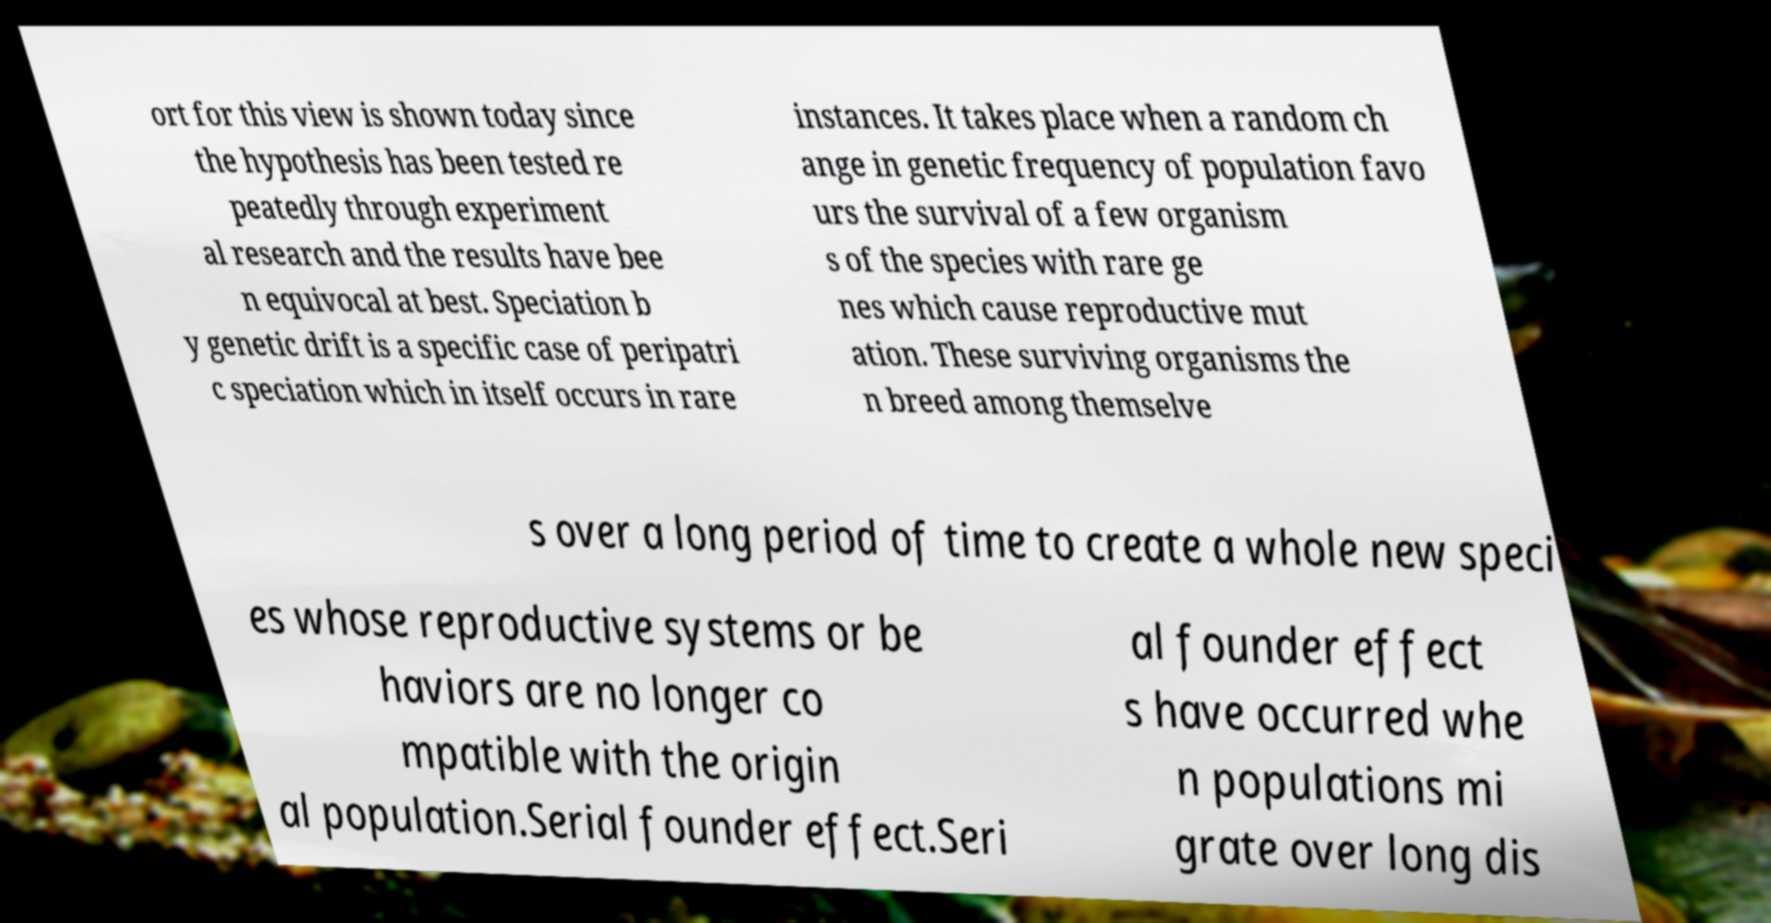Could you extract and type out the text from this image? ort for this view is shown today since the hypothesis has been tested re peatedly through experiment al research and the results have bee n equivocal at best. Speciation b y genetic drift is a specific case of peripatri c speciation which in itself occurs in rare instances. It takes place when a random ch ange in genetic frequency of population favo urs the survival of a few organism s of the species with rare ge nes which cause reproductive mut ation. These surviving organisms the n breed among themselve s over a long period of time to create a whole new speci es whose reproductive systems or be haviors are no longer co mpatible with the origin al population.Serial founder effect.Seri al founder effect s have occurred whe n populations mi grate over long dis 